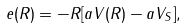Convert formula to latex. <formula><loc_0><loc_0><loc_500><loc_500>e ( R ) = - R [ a V ( R ) - a V _ { S } ] ,</formula> 